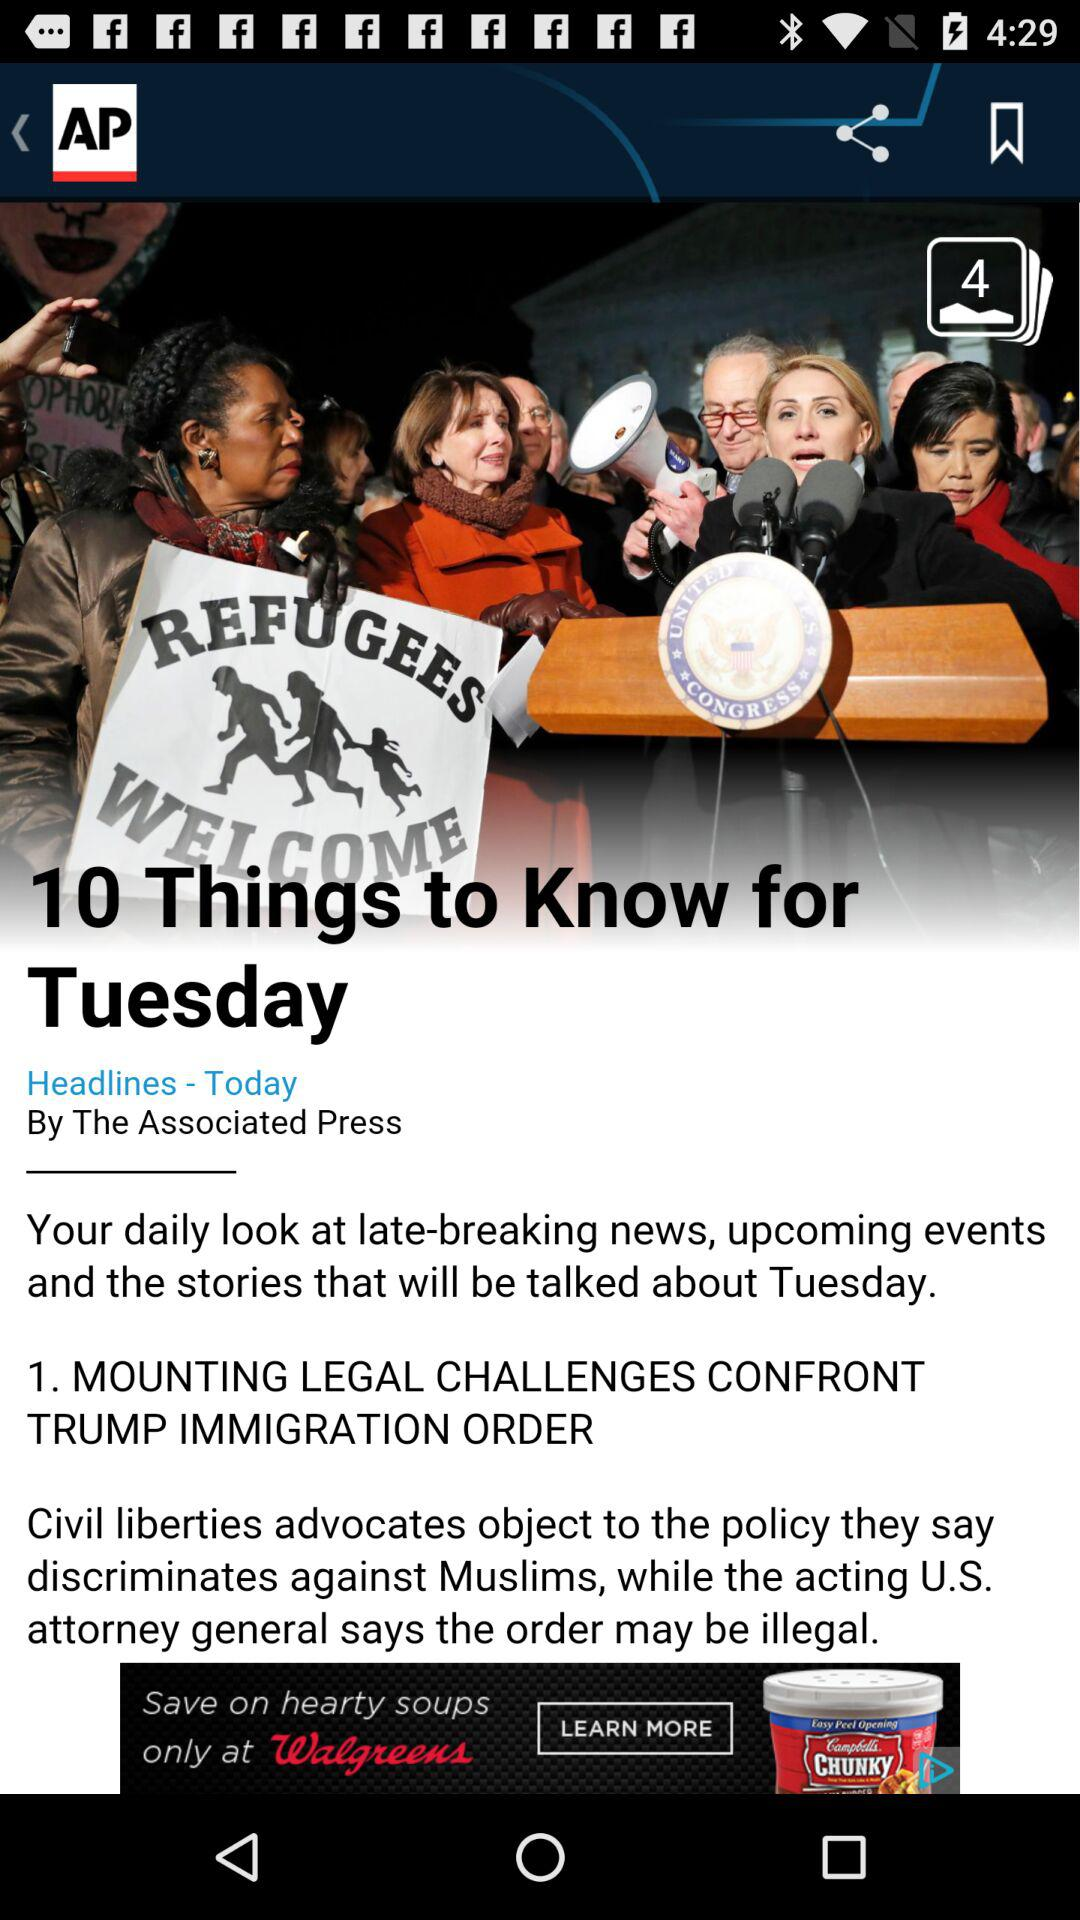When was this headline published? This headline was published today. 